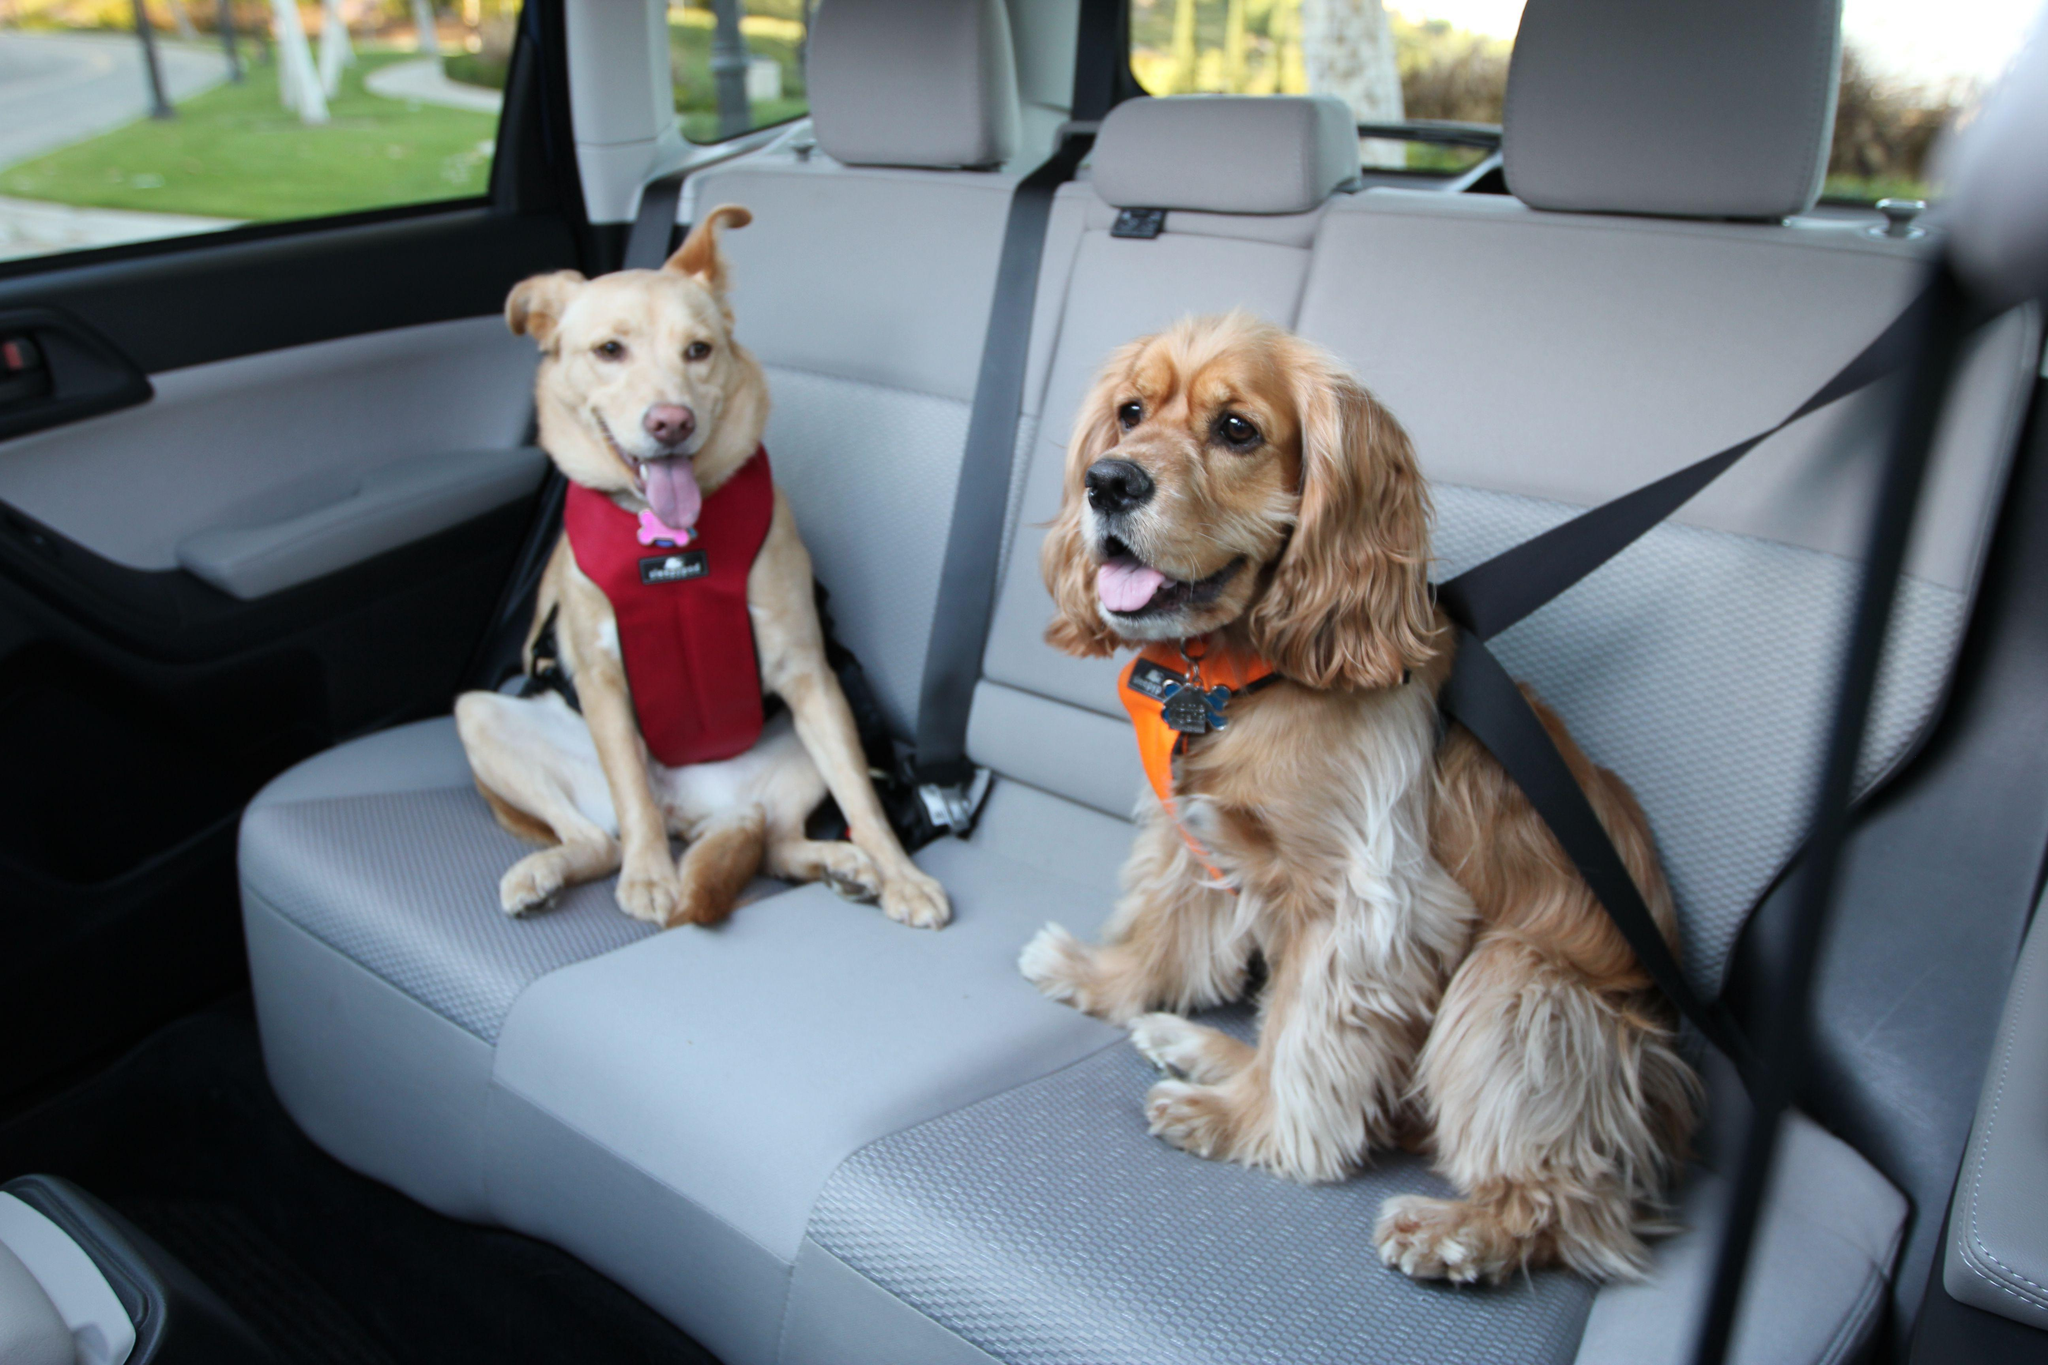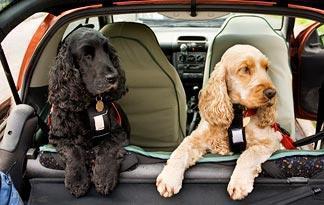The first image is the image on the left, the second image is the image on the right. Considering the images on both sides, is "Each image shows one spaniel riding in a car, and one image shows a spaniel sitting in a soft-sided box suspended over a seat by seat belts." valid? Answer yes or no. No. The first image is the image on the left, the second image is the image on the right. Given the left and right images, does the statement "One dog is riding in a carrier." hold true? Answer yes or no. No. 